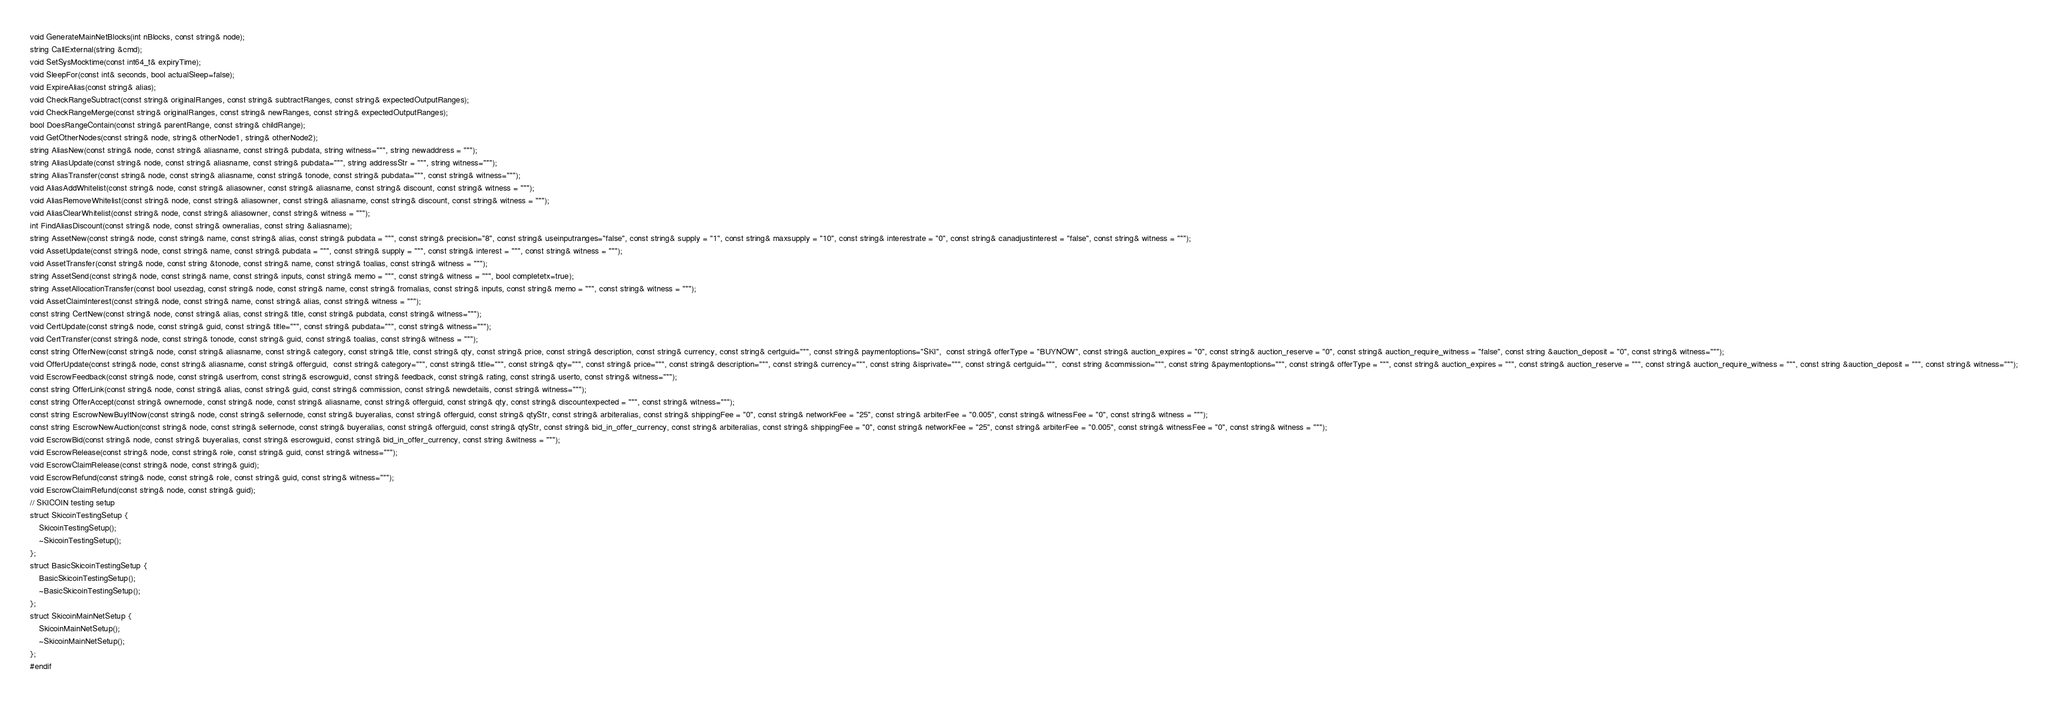Convert code to text. <code><loc_0><loc_0><loc_500><loc_500><_C_>void GenerateMainNetBlocks(int nBlocks, const string& node);
string CallExternal(string &cmd);
void SetSysMocktime(const int64_t& expiryTime);
void SleepFor(const int& seconds, bool actualSleep=false);
void ExpireAlias(const string& alias);
void CheckRangeSubtract(const string& originalRanges, const string& subtractRanges, const string& expectedOutputRanges);
void CheckRangeMerge(const string& originalRanges, const string& newRanges, const string& expectedOutputRanges);
bool DoesRangeContain(const string& parentRange, const string& childRange);
void GetOtherNodes(const string& node, string& otherNode1, string& otherNode2);
string AliasNew(const string& node, const string& aliasname, const string& pubdata, string witness="''", string newaddress = "''");
string AliasUpdate(const string& node, const string& aliasname, const string& pubdata="''", string addressStr = "''", string witness="''");
string AliasTransfer(const string& node, const string& aliasname, const string& tonode, const string& pubdata="''", const string& witness="''");
void AliasAddWhitelist(const string& node, const string& aliasowner, const string& aliasname, const string& discount, const string& witness = "''");
void AliasRemoveWhitelist(const string& node, const string& aliasowner, const string& aliasname, const string& discount, const string& witness = "''");
void AliasClearWhitelist(const string& node, const string& aliasowner, const string& witness = "''");
int FindAliasDiscount(const string& node, const string& owneralias, const string &aliasname);
string AssetNew(const string& node, const string& name, const string& alias, const string& pubdata = "''", const string& precision="8", const string& useinputranges="false", const string& supply = "1", const string& maxsupply = "10", const string& interestrate = "0", const string& canadjustinterest = "false", const string& witness = "''");
void AssetUpdate(const string& node, const string& name, const string& pubdata = "''", const string& supply = "''", const string& interest = "''", const string& witness = "''");
void AssetTransfer(const string& node, const string &tonode, const string& name, const string& toalias, const string& witness = "''");
string AssetSend(const string& node, const string& name, const string& inputs, const string& memo = "''", const string& witness = "''", bool completetx=true);
string AssetAllocationTransfer(const bool usezdag, const string& node, const string& name, const string& fromalias, const string& inputs, const string& memo = "''", const string& witness = "''");
void AssetClaimInterest(const string& node, const string& name, const string& alias, const string& witness = "''");
const string CertNew(const string& node, const string& alias, const string& title, const string& pubdata, const string& witness="''");
void CertUpdate(const string& node, const string& guid, const string& title="''", const string& pubdata="''", const string& witness="''");
void CertTransfer(const string& node, const string& tonode, const string& guid, const string& toalias, const string& witness = "''");
const string OfferNew(const string& node, const string& aliasname, const string& category, const string& title, const string& qty, const string& price, const string& description, const string& currency, const string& certguid="''", const string& paymentoptions="SKI",  const string& offerType = "BUYNOW", const string& auction_expires = "0", const string& auction_reserve = "0", const string& auction_require_witness = "false", const string &auction_deposit = "0", const string& witness="''");
void OfferUpdate(const string& node, const string& aliasname, const string& offerguid,  const string& category="''", const string& title="''", const string& qty="''", const string& price="''", const string& description="''", const string& currency="''", const string &isprivate="''", const string& certguid="''",  const string &commission="''", const string &paymentoptions="''", const string& offerType = "''", const string& auction_expires = "''", const string& auction_reserve = "''", const string& auction_require_witness = "''", const string &auction_deposit = "''", const string& witness="''");
void EscrowFeedback(const string& node, const string& userfrom, const string& escrowguid, const string& feedback, const string& rating, const string& userto, const string& witness="''");
const string OfferLink(const string& node, const string& alias, const string& guid, const string& commission, const string& newdetails, const string& witness="''");
const string OfferAccept(const string& ownernode, const string& node, const string& aliasname, const string& offerguid, const string& qty, const string& discountexpected = "''", const string& witness="''");
const string EscrowNewBuyItNow(const string& node, const string& sellernode, const string& buyeralias, const string& offerguid, const string& qtyStr, const string& arbiteralias, const string& shippingFee = "0", const string& networkFee = "25", const string& arbiterFee = "0.005", const string& witnessFee = "0", const string& witness = "''");
const string EscrowNewAuction(const string& node, const string& sellernode, const string& buyeralias, const string& offerguid, const string& qtyStr, const string& bid_in_offer_currency, const string& arbiteralias, const string& shippingFee = "0", const string& networkFee = "25", const string& arbiterFee = "0.005", const string& witnessFee = "0", const string& witness = "''");
void EscrowBid(const string& node, const string& buyeralias, const string& escrowguid, const string& bid_in_offer_currency, const string &witness = "''");
void EscrowRelease(const string& node, const string& role, const string& guid, const string& witness="''");
void EscrowClaimRelease(const string& node, const string& guid);
void EscrowRefund(const string& node, const string& role, const string& guid, const string& witness="''");
void EscrowClaimRefund(const string& node, const string& guid);
// SKICOIN testing setup
struct SkicoinTestingSetup {
    SkicoinTestingSetup();
    ~SkicoinTestingSetup();
};
struct BasicSkicoinTestingSetup {
    BasicSkicoinTestingSetup();
    ~BasicSkicoinTestingSetup();
};
struct SkicoinMainNetSetup {
	SkicoinMainNetSetup();
	~SkicoinMainNetSetup();
};
#endif
</code> 